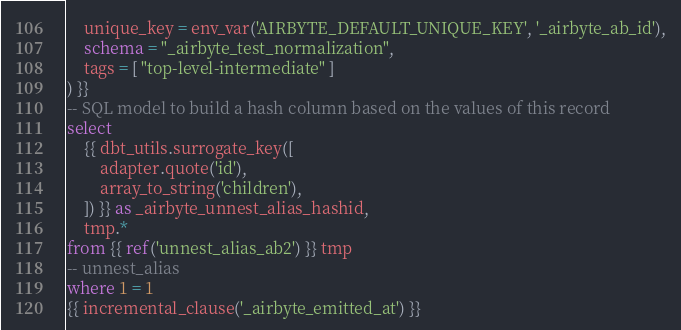Convert code to text. <code><loc_0><loc_0><loc_500><loc_500><_SQL_>    unique_key = env_var('AIRBYTE_DEFAULT_UNIQUE_KEY', '_airbyte_ab_id'),
    schema = "_airbyte_test_normalization",
    tags = [ "top-level-intermediate" ]
) }}
-- SQL model to build a hash column based on the values of this record
select
    {{ dbt_utils.surrogate_key([
        adapter.quote('id'),
        array_to_string('children'),
    ]) }} as _airbyte_unnest_alias_hashid,
    tmp.*
from {{ ref('unnest_alias_ab2') }} tmp
-- unnest_alias
where 1 = 1
{{ incremental_clause('_airbyte_emitted_at') }}

</code> 